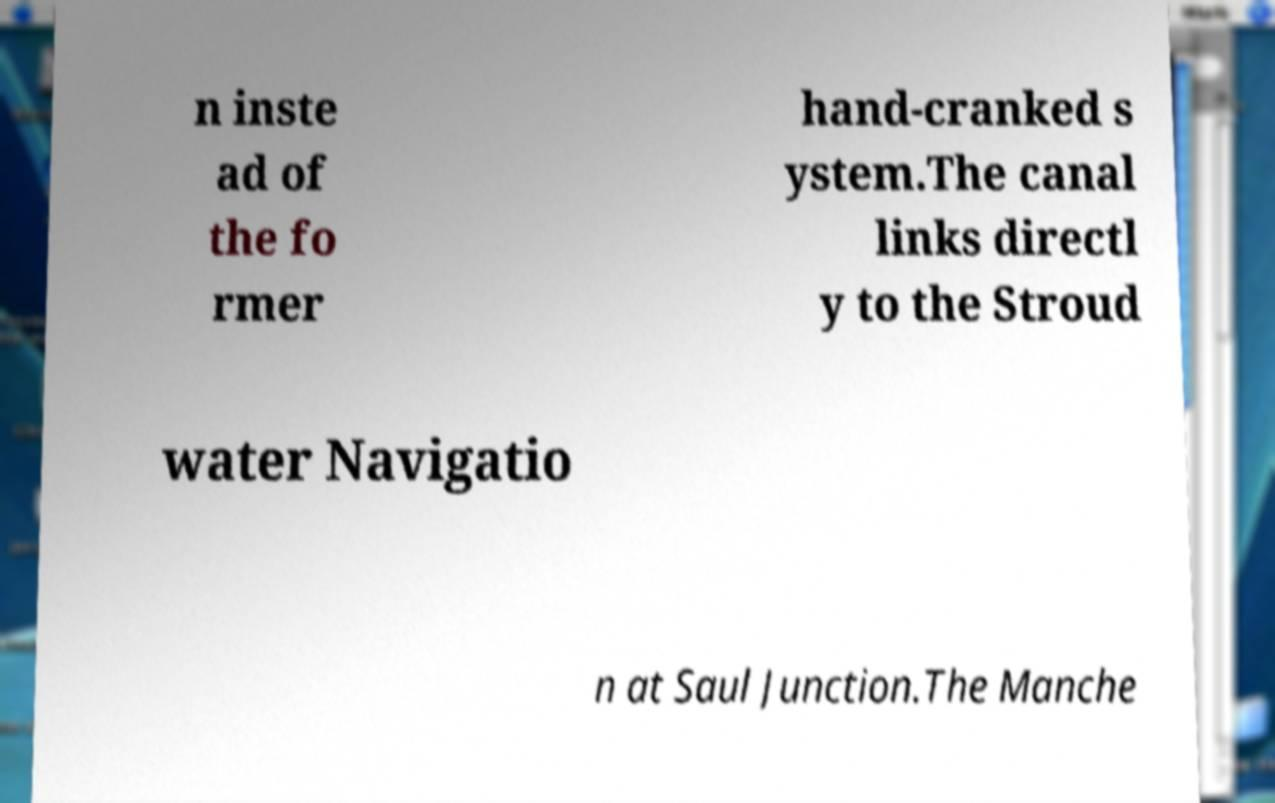Could you extract and type out the text from this image? n inste ad of the fo rmer hand-cranked s ystem.The canal links directl y to the Stroud water Navigatio n at Saul Junction.The Manche 